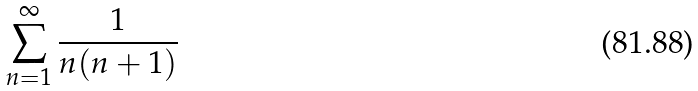<formula> <loc_0><loc_0><loc_500><loc_500>\sum _ { n = 1 } ^ { \infty } \frac { 1 } { n ( n + 1 ) }</formula> 